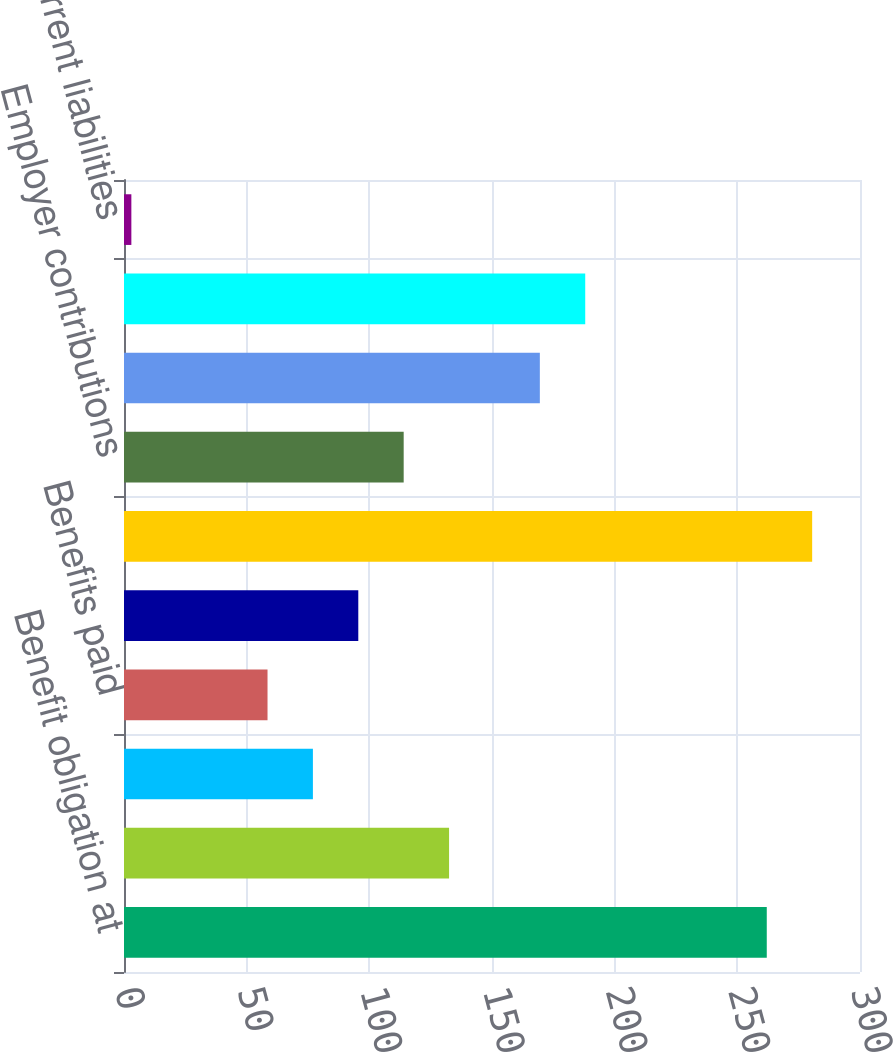Convert chart. <chart><loc_0><loc_0><loc_500><loc_500><bar_chart><fcel>Benefit obligation at<fcel>Service cost<fcel>Interest cost<fcel>Benefits paid<fcel>Actuarial (gain) loss<fcel>Benefit obligation at end of<fcel>Employer contributions<fcel>Funded status at end of year<fcel>balance sheets (after adoption<fcel>Current liabilities<nl><fcel>262<fcel>132.5<fcel>77<fcel>58.5<fcel>95.5<fcel>280.5<fcel>114<fcel>169.5<fcel>188<fcel>3<nl></chart> 